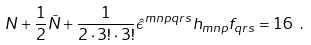Convert formula to latex. <formula><loc_0><loc_0><loc_500><loc_500>N + \frac { 1 } { 2 } \tilde { N } + \frac { 1 } { 2 \cdot 3 ! \cdot 3 ! } \hat { \epsilon } ^ { m n p q r s } h _ { m n p } f _ { q r s } = 1 6 \ .</formula> 